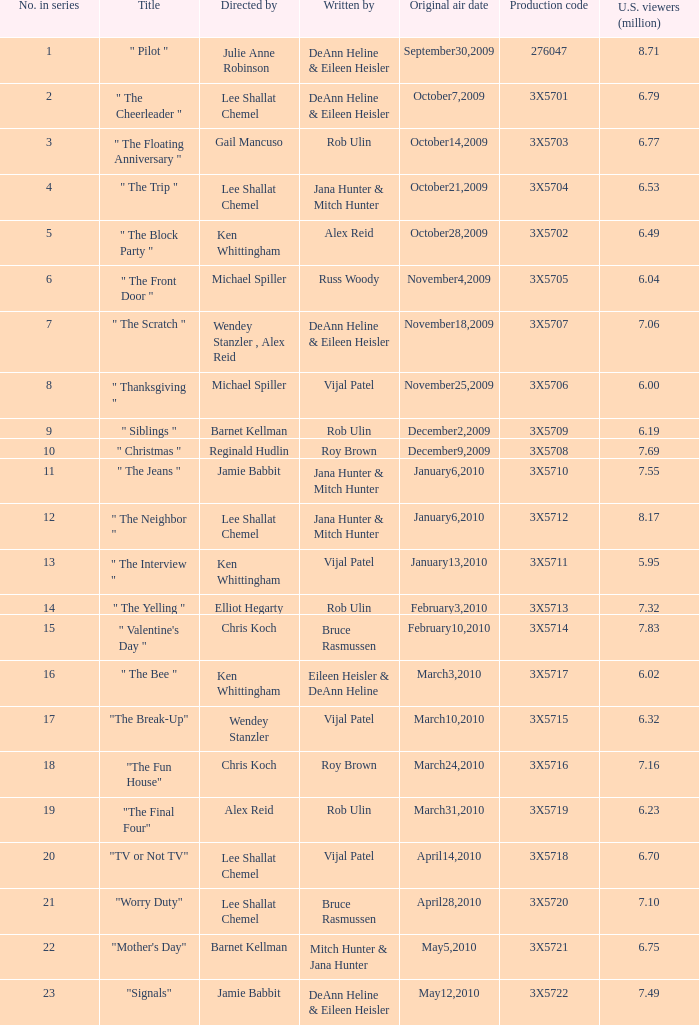95 million u.s. viewers? Vijal Patel. 